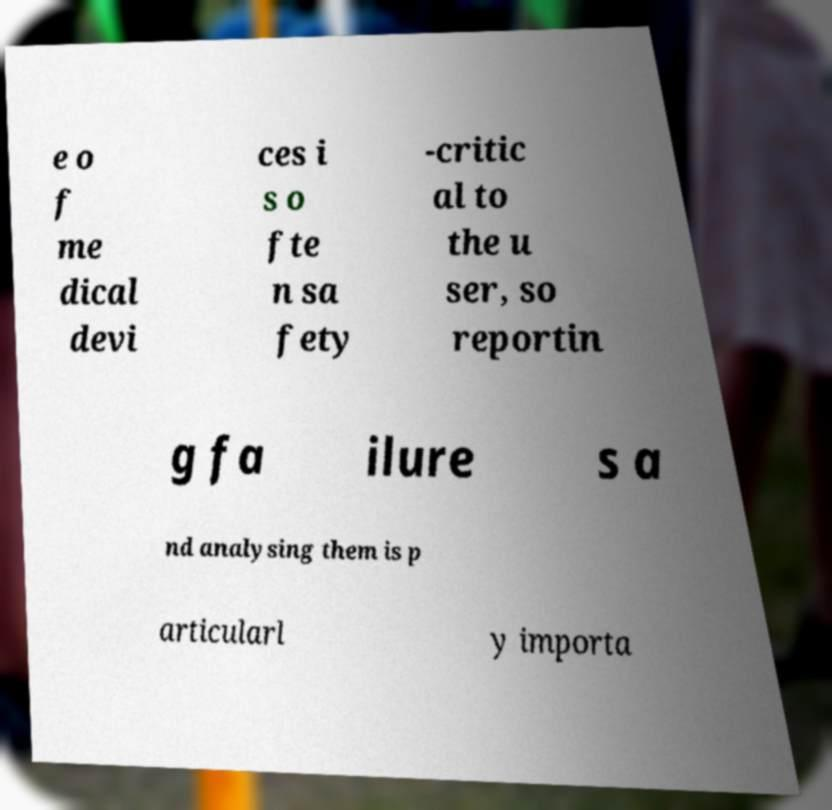I need the written content from this picture converted into text. Can you do that? e o f me dical devi ces i s o fte n sa fety -critic al to the u ser, so reportin g fa ilure s a nd analysing them is p articularl y importa 